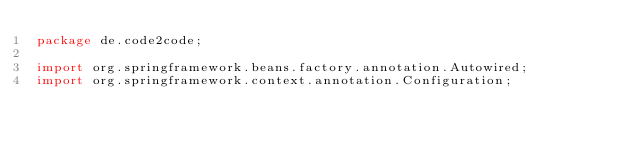<code> <loc_0><loc_0><loc_500><loc_500><_Java_>package de.code2code;

import org.springframework.beans.factory.annotation.Autowired;
import org.springframework.context.annotation.Configuration;</code> 